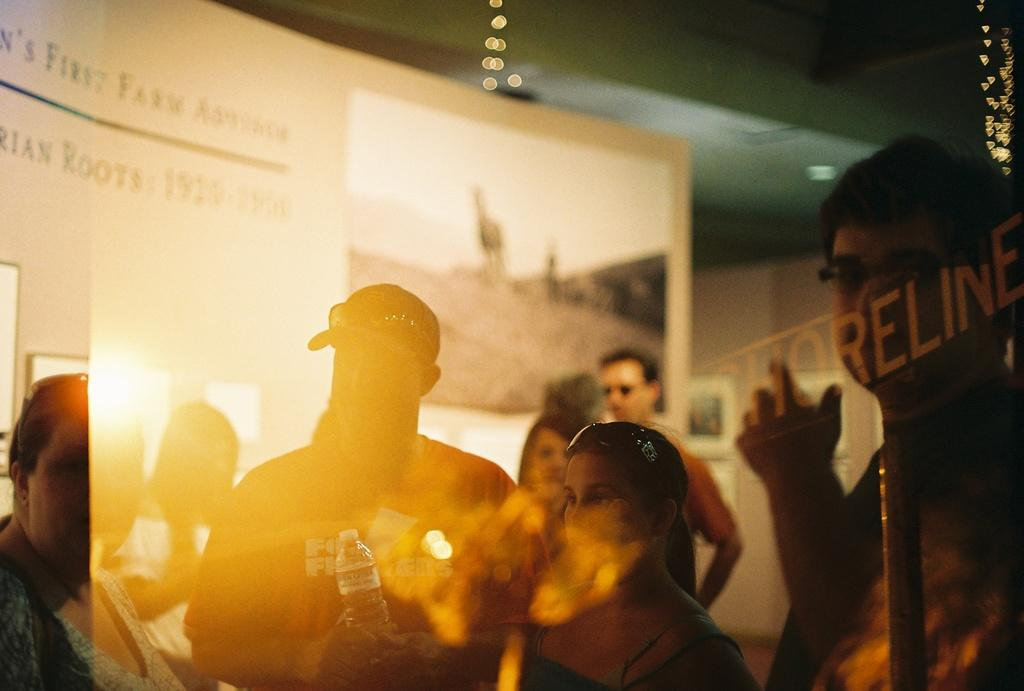How many people are in the image? There are persons in the image, but the exact number is not specified. What can be found in the right corner of the image? There is text in the right corner of the image. What else is present in the image besides the persons? There are images in the image. What can be found in the left corner of the image? There is text in the left corner of the image. What type of straw is being used to drink from the bottle in the image? There is no bottle or straw present in the image. 